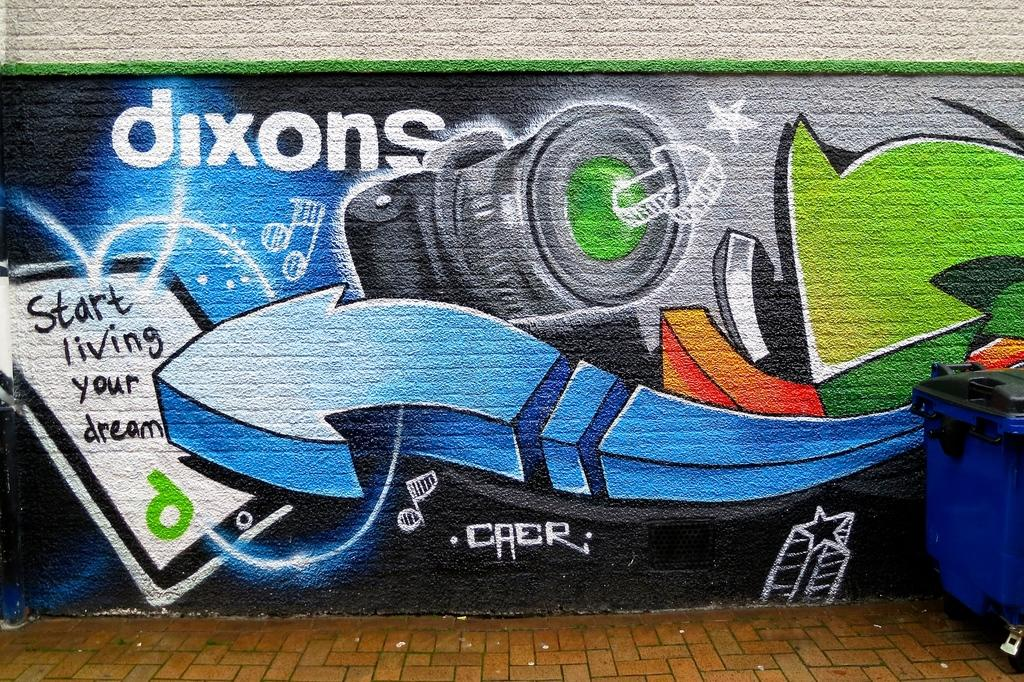Provide a one-sentence caption for the provided image. Art is displayed on the wall related to the Dixon camera and tablet. 